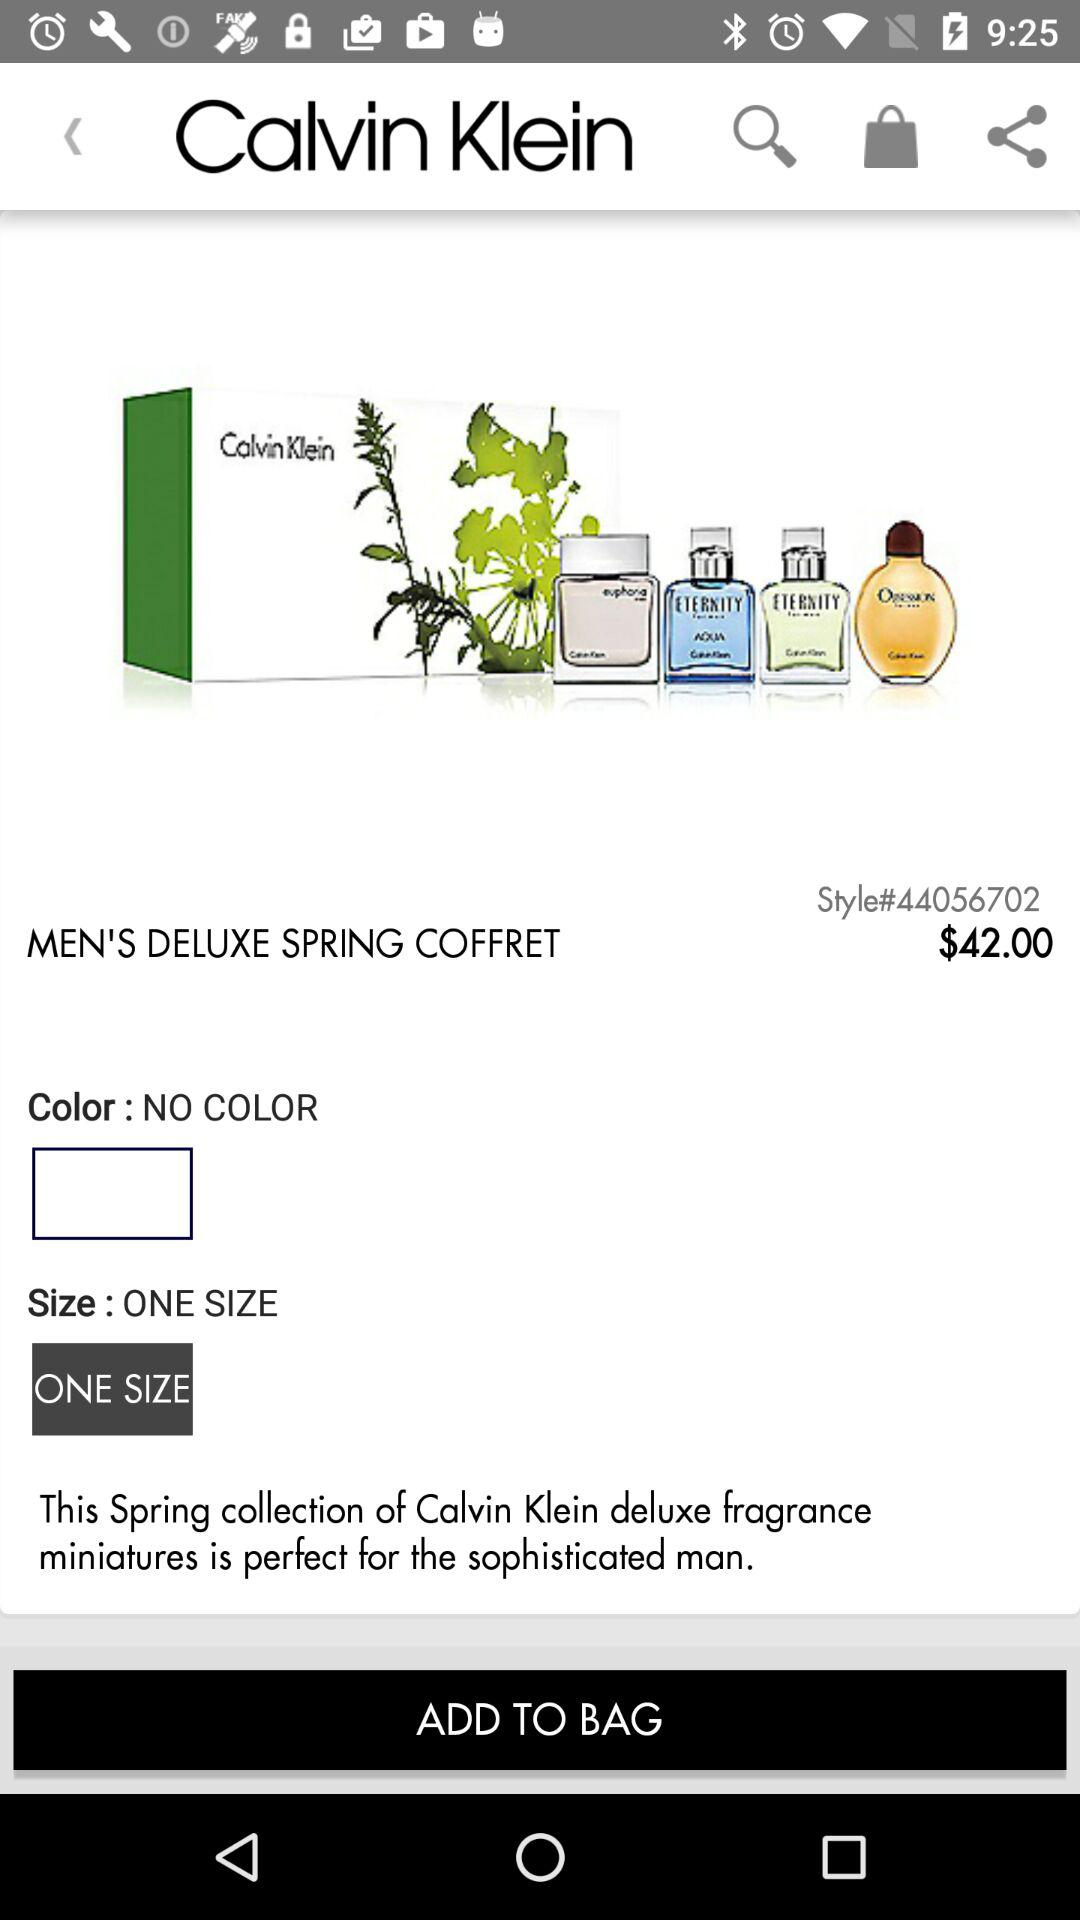What is the cost of the perfumes? The cost of the perfumes is $42. 